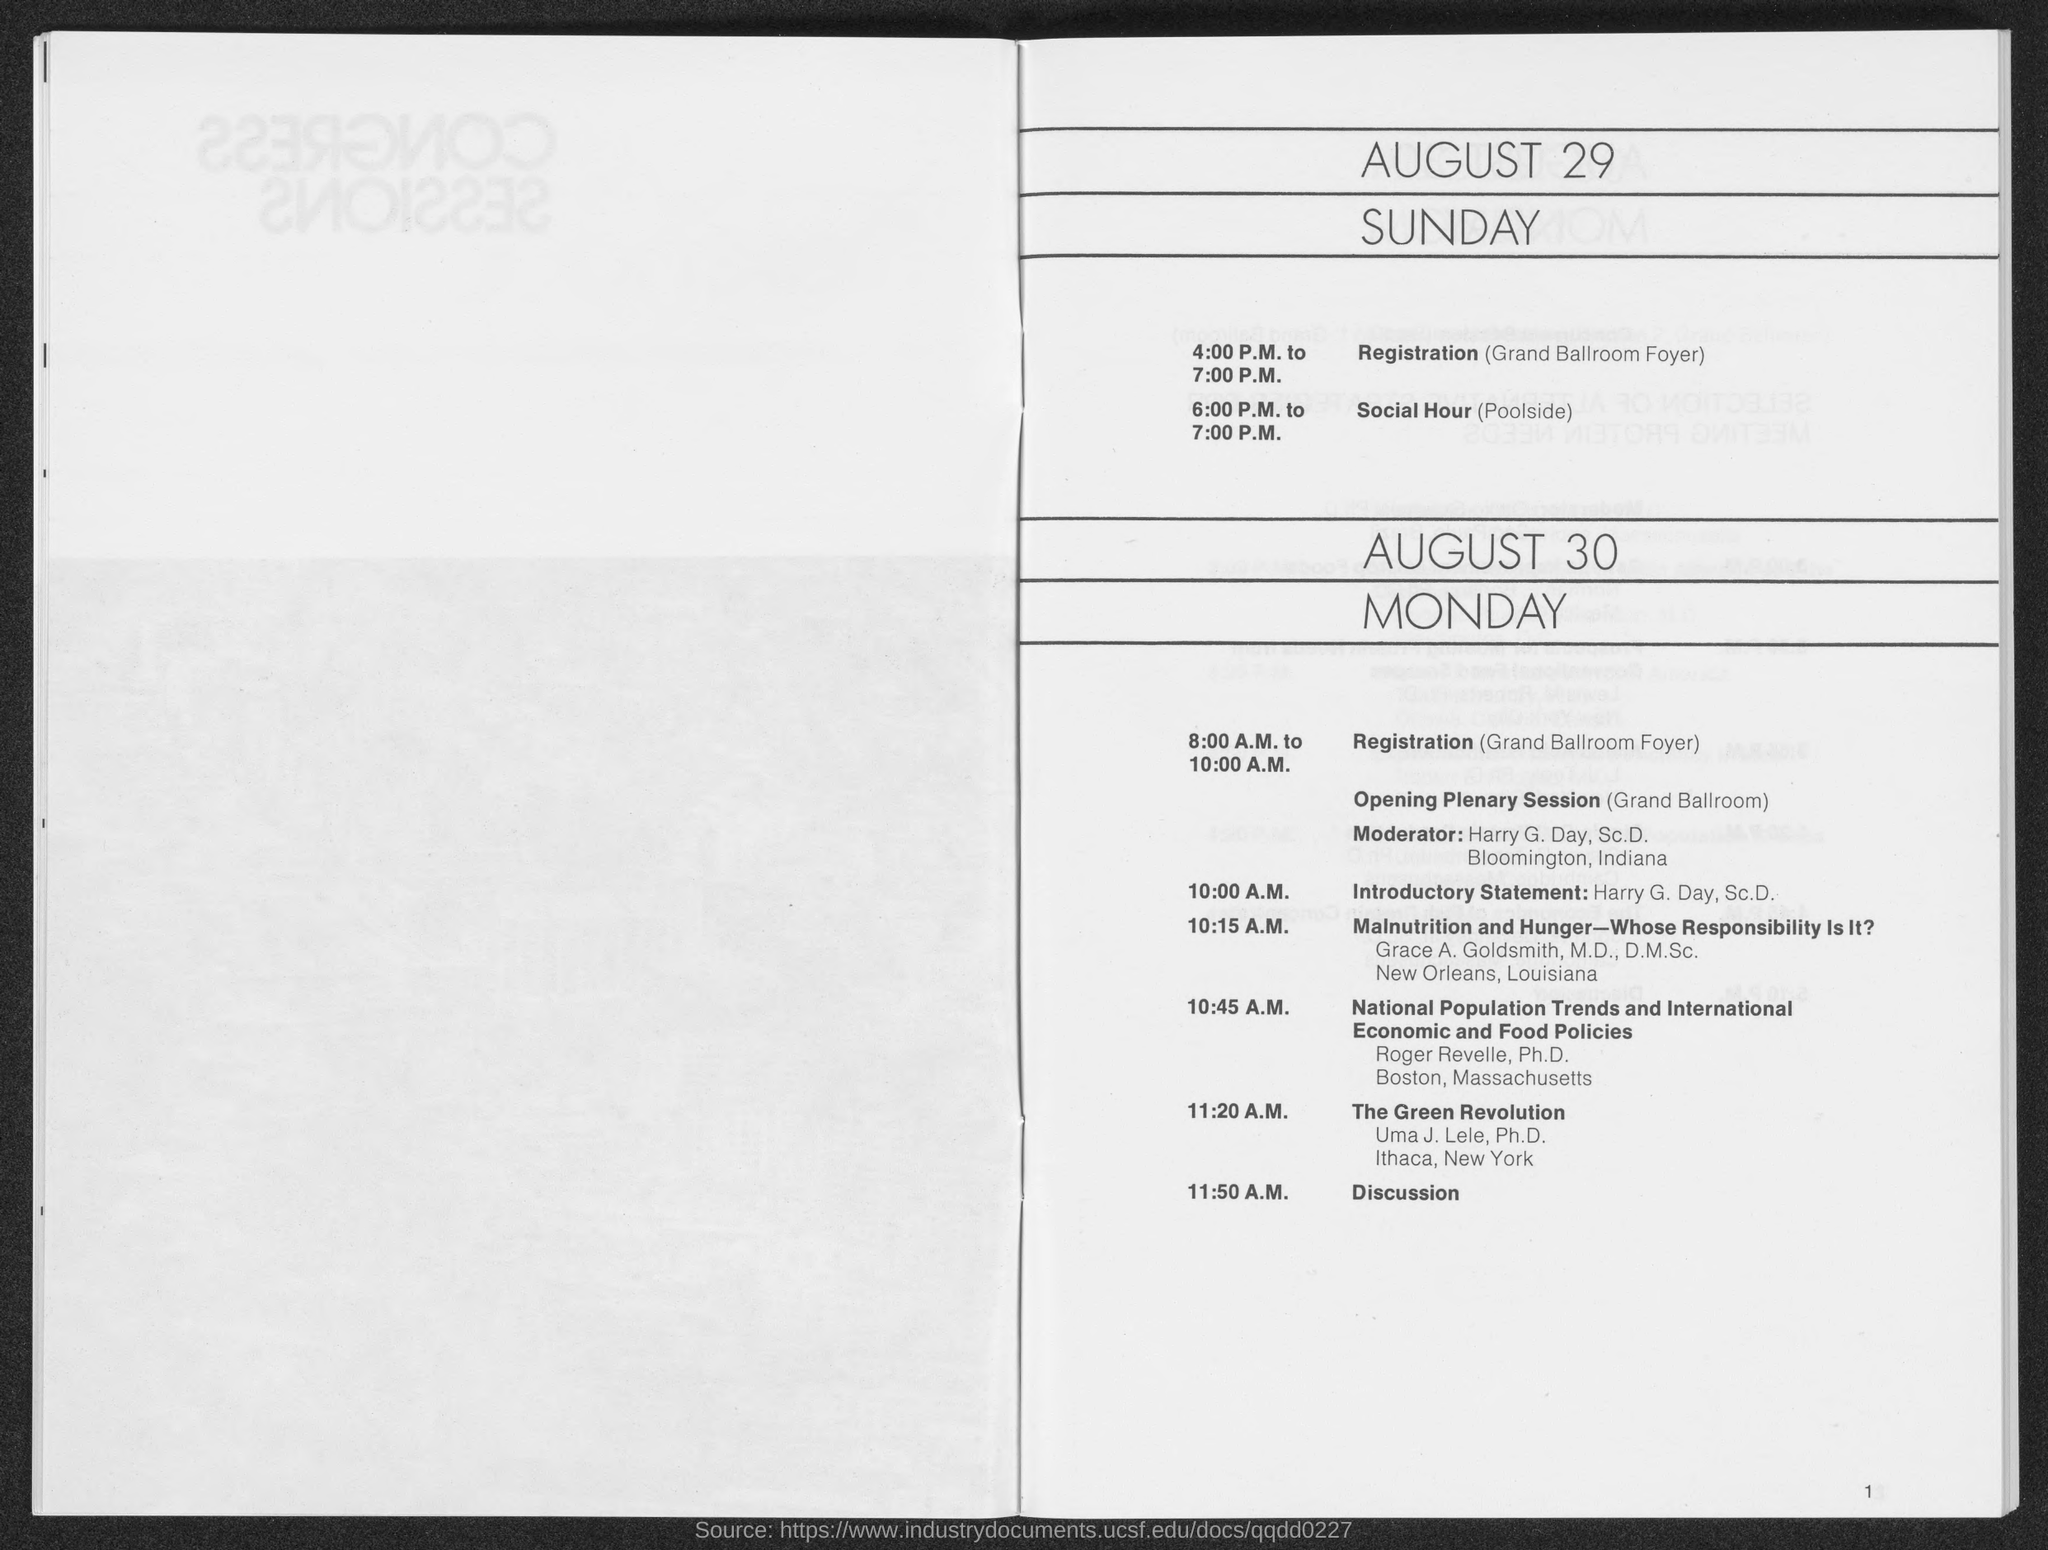What is the time of registration mentioned on August 29?
Your answer should be very brief. 4.00 P.M. to 7.00 P.M. What is the time of registration mentioned on August 30?
Keep it short and to the point. 8:00 A.M. to 10:00 A.M. What is the session after "The Green Revolution" ?
Your answer should be very brief. Discussion. What is the session at 6:00 P.M. to 7:00 P.M.?
Your answer should be compact. Social Hour. 